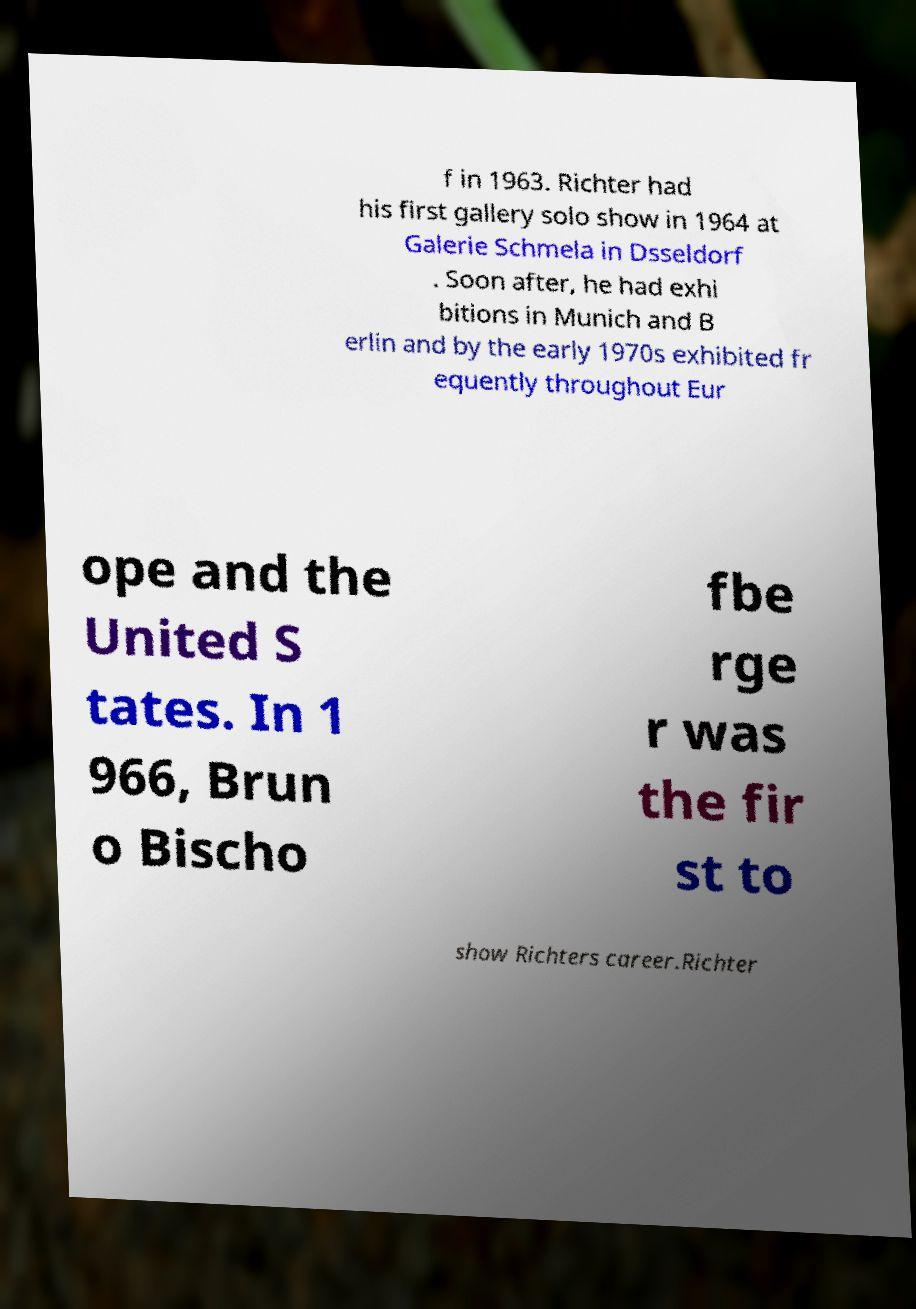There's text embedded in this image that I need extracted. Can you transcribe it verbatim? f in 1963. Richter had his first gallery solo show in 1964 at Galerie Schmela in Dsseldorf . Soon after, he had exhi bitions in Munich and B erlin and by the early 1970s exhibited fr equently throughout Eur ope and the United S tates. In 1 966, Brun o Bischo fbe rge r was the fir st to show Richters career.Richter 